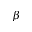Convert formula to latex. <formula><loc_0><loc_0><loc_500><loc_500>\beta</formula> 